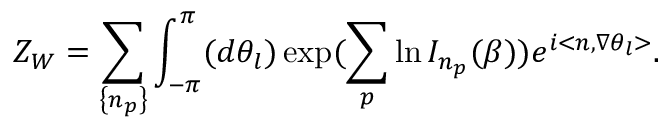Convert formula to latex. <formula><loc_0><loc_0><loc_500><loc_500>Z _ { W } = \sum _ { \left \{ n _ { p } \right \} } \int _ { - \pi } ^ { \pi } ( d \theta _ { l } ) \exp ( \sum _ { p } \ln I _ { n _ { p } } ( \beta ) ) e ^ { i < n , \nabla \theta _ { l } > } .</formula> 